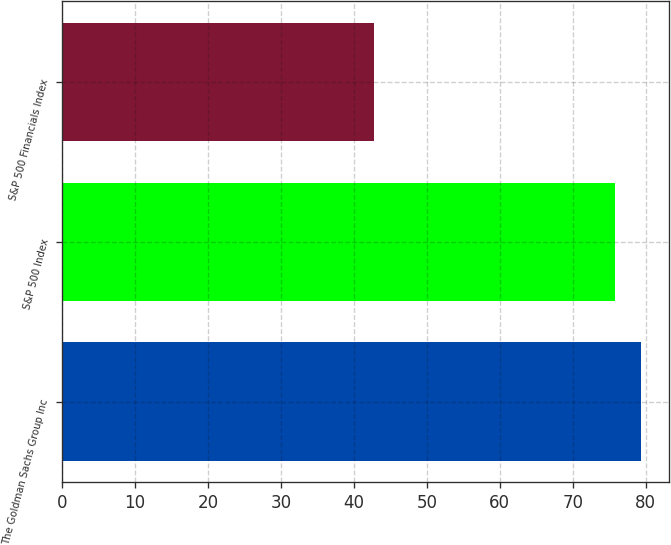Convert chart to OTSL. <chart><loc_0><loc_0><loc_500><loc_500><bar_chart><fcel>The Goldman Sachs Group Inc<fcel>S&P 500 Index<fcel>S&P 500 Financials Index<nl><fcel>79.31<fcel>75.78<fcel>42.78<nl></chart> 